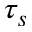Convert formula to latex. <formula><loc_0><loc_0><loc_500><loc_500>\tau _ { s }</formula> 